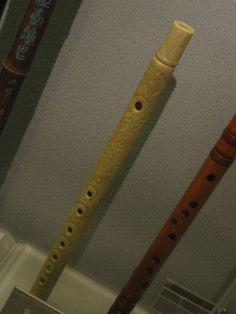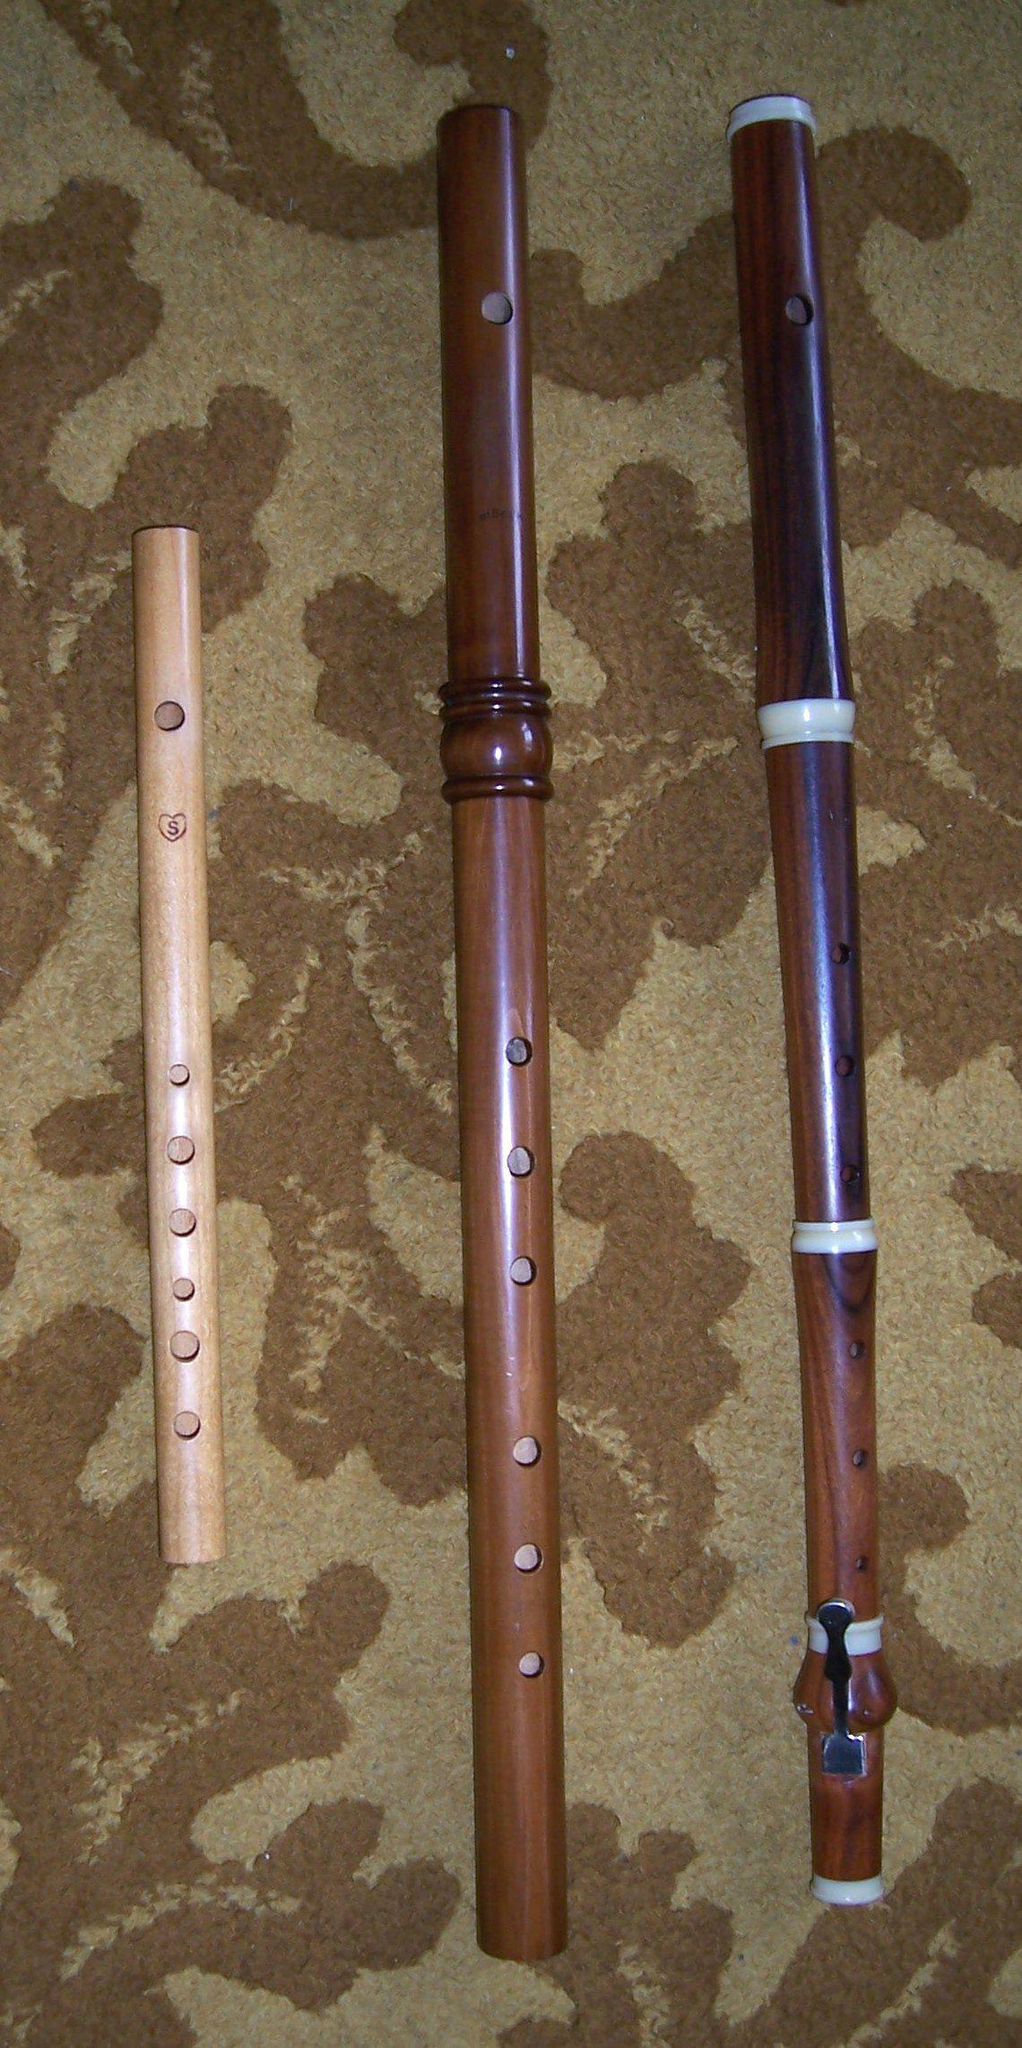The first image is the image on the left, the second image is the image on the right. Evaluate the accuracy of this statement regarding the images: "There are two flutes.". Is it true? Answer yes or no. No. 